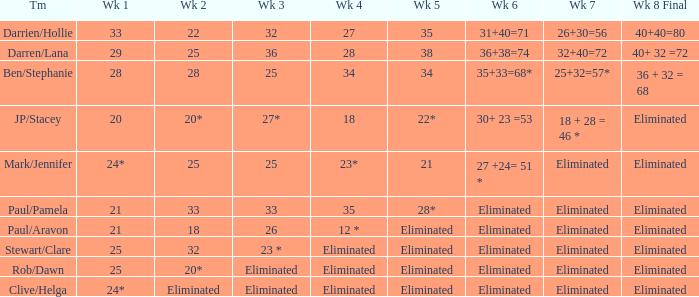Name the week 3 of 36 29.0. 